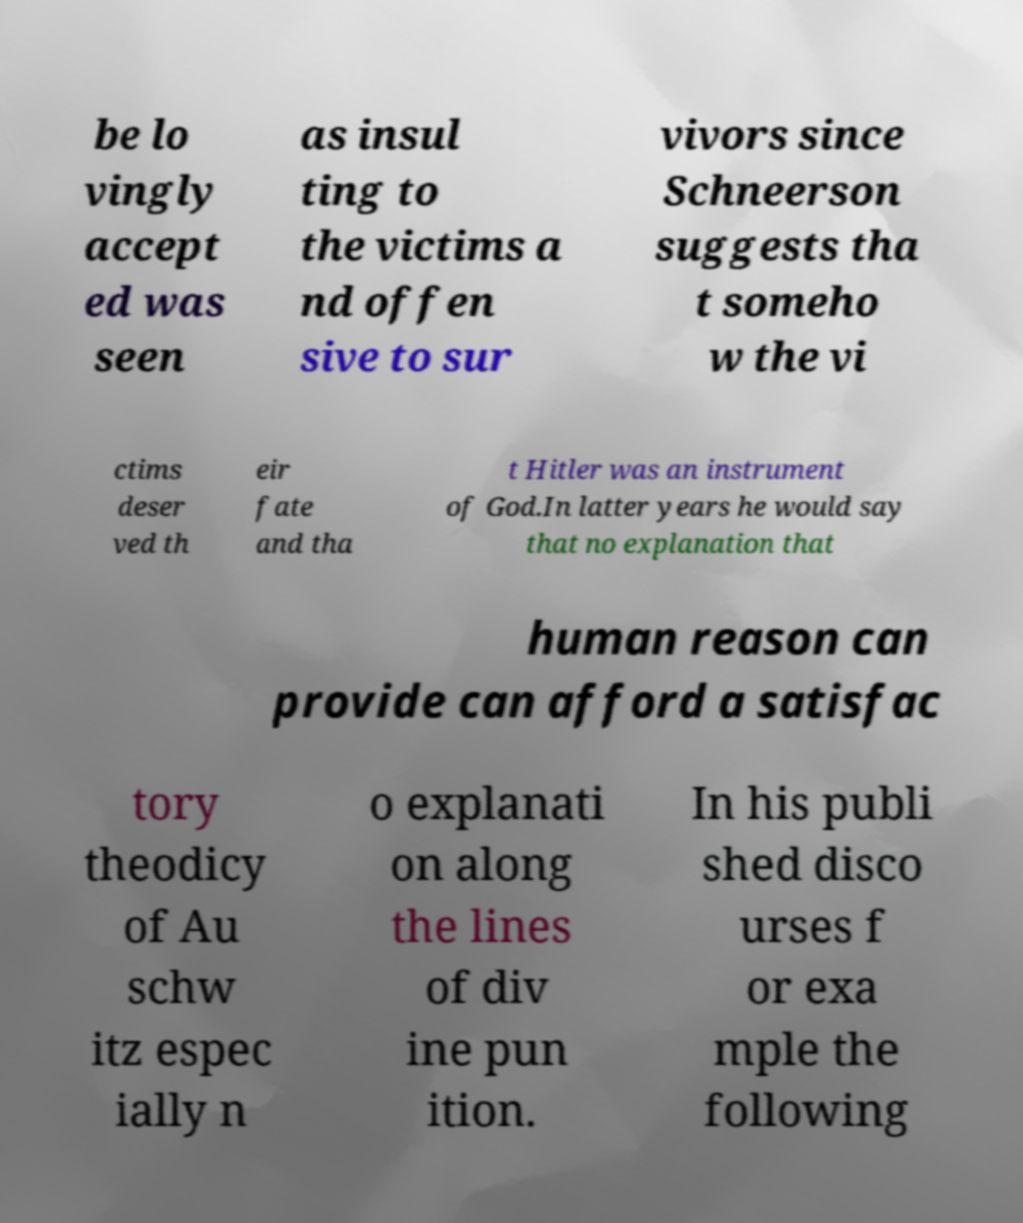There's text embedded in this image that I need extracted. Can you transcribe it verbatim? be lo vingly accept ed was seen as insul ting to the victims a nd offen sive to sur vivors since Schneerson suggests tha t someho w the vi ctims deser ved th eir fate and tha t Hitler was an instrument of God.In latter years he would say that no explanation that human reason can provide can afford a satisfac tory theodicy of Au schw itz espec ially n o explanati on along the lines of div ine pun ition. In his publi shed disco urses f or exa mple the following 